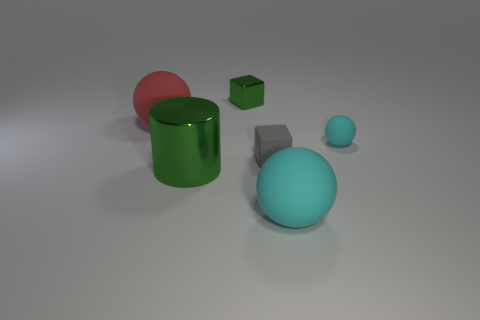Add 2 yellow metallic cubes. How many objects exist? 8 Subtract all cylinders. How many objects are left? 5 Add 6 big brown rubber balls. How many big brown rubber balls exist? 6 Subtract 1 green cubes. How many objects are left? 5 Subtract all gray cubes. Subtract all small green cubes. How many objects are left? 4 Add 5 gray blocks. How many gray blocks are left? 6 